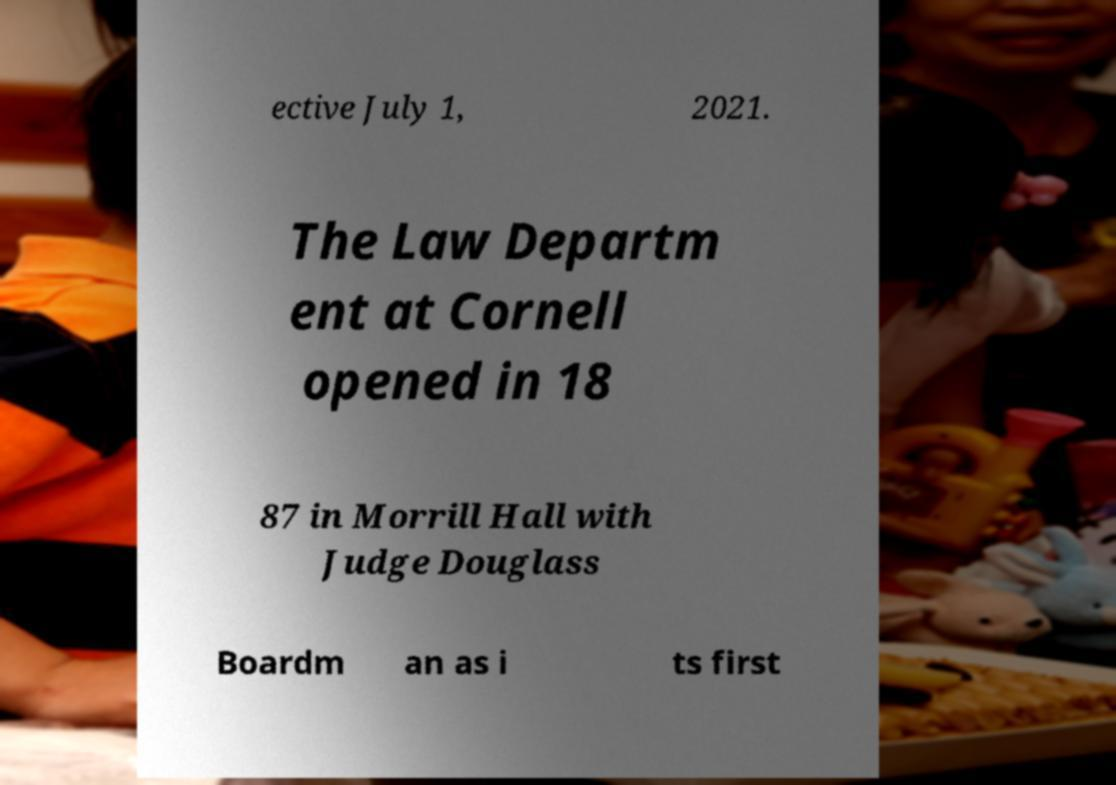There's text embedded in this image that I need extracted. Can you transcribe it verbatim? ective July 1, 2021. The Law Departm ent at Cornell opened in 18 87 in Morrill Hall with Judge Douglass Boardm an as i ts first 